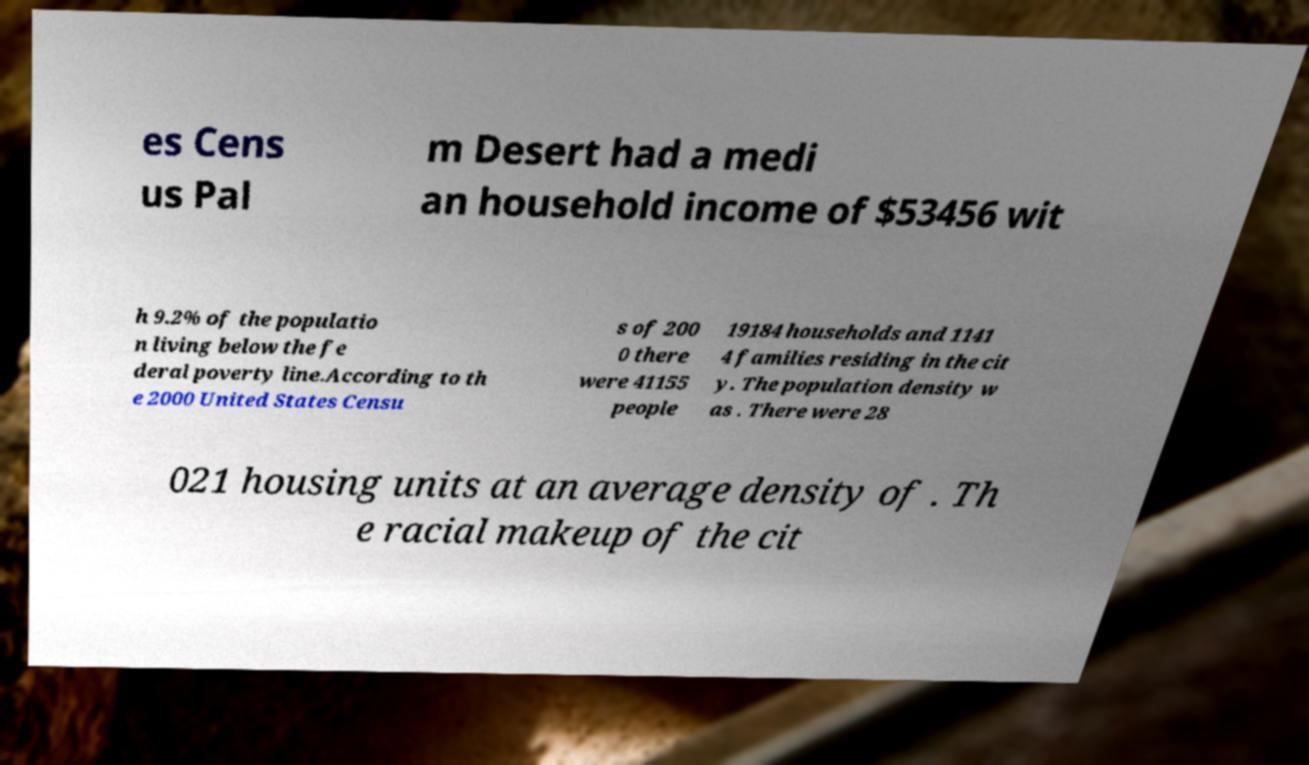There's text embedded in this image that I need extracted. Can you transcribe it verbatim? es Cens us Pal m Desert had a medi an household income of $53456 wit h 9.2% of the populatio n living below the fe deral poverty line.According to th e 2000 United States Censu s of 200 0 there were 41155 people 19184 households and 1141 4 families residing in the cit y. The population density w as . There were 28 021 housing units at an average density of . Th e racial makeup of the cit 